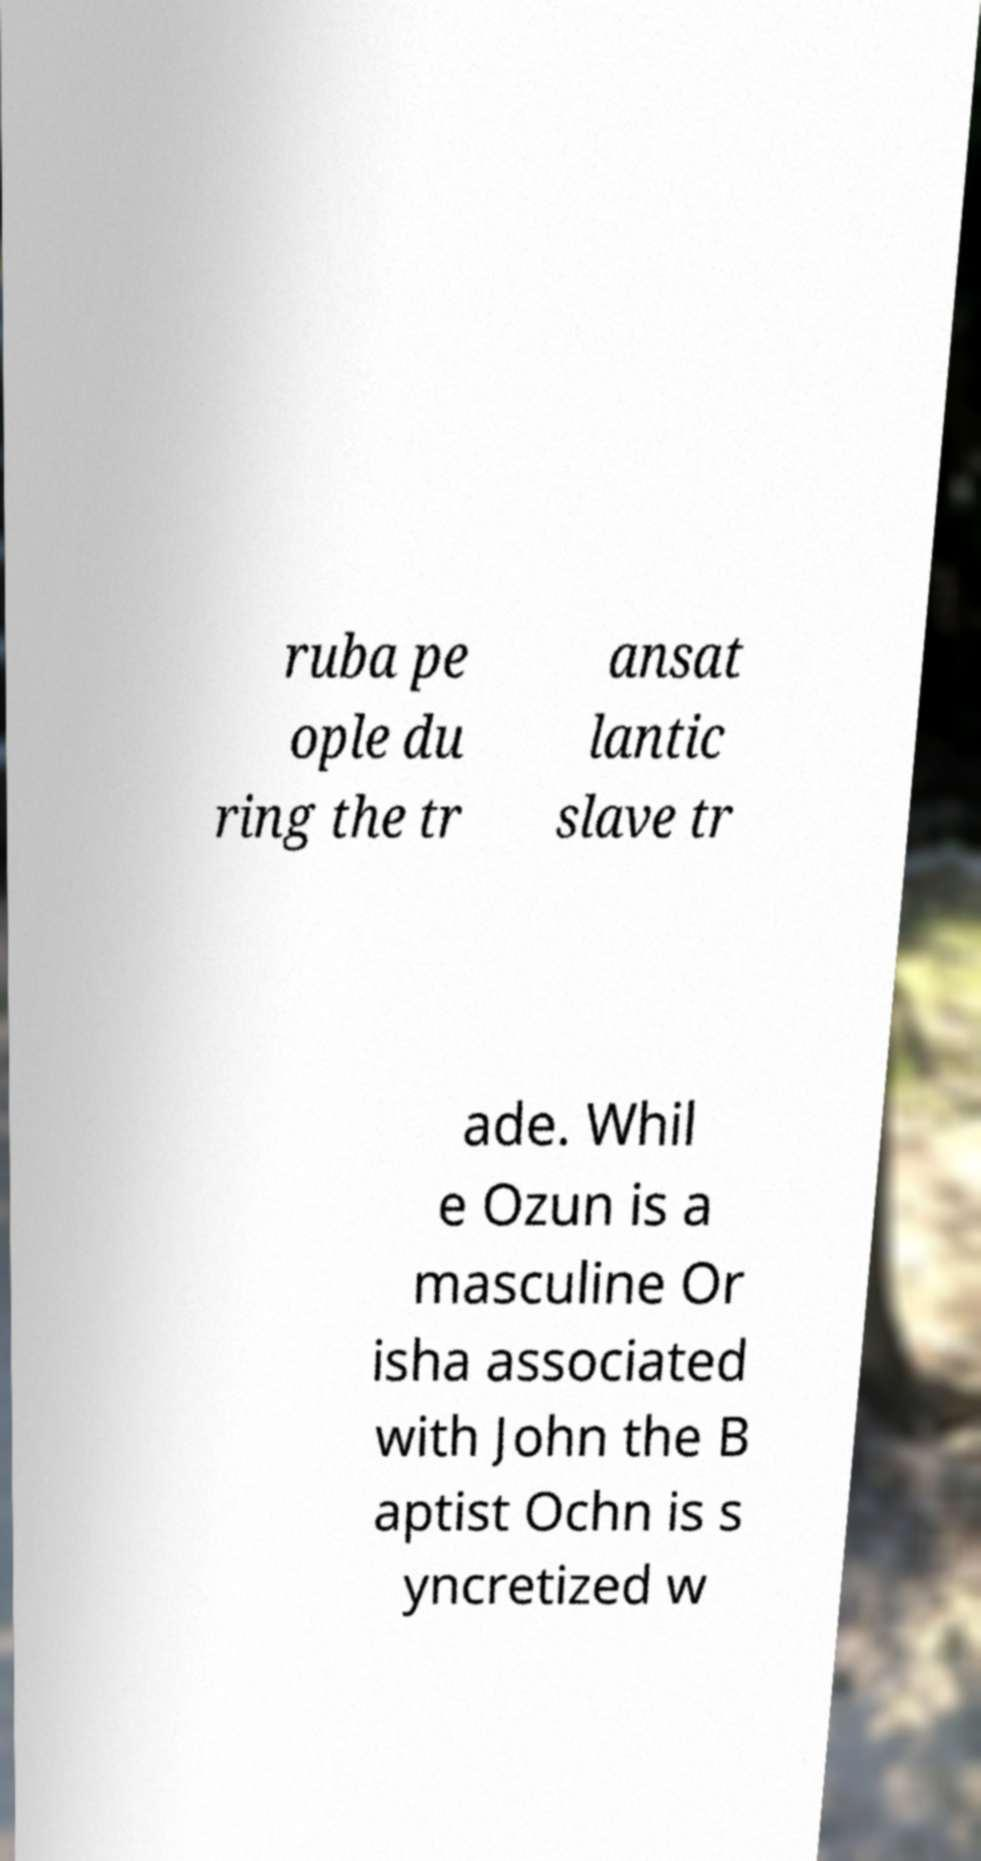I need the written content from this picture converted into text. Can you do that? ruba pe ople du ring the tr ansat lantic slave tr ade. Whil e Ozun is a masculine Or isha associated with John the B aptist Ochn is s yncretized w 